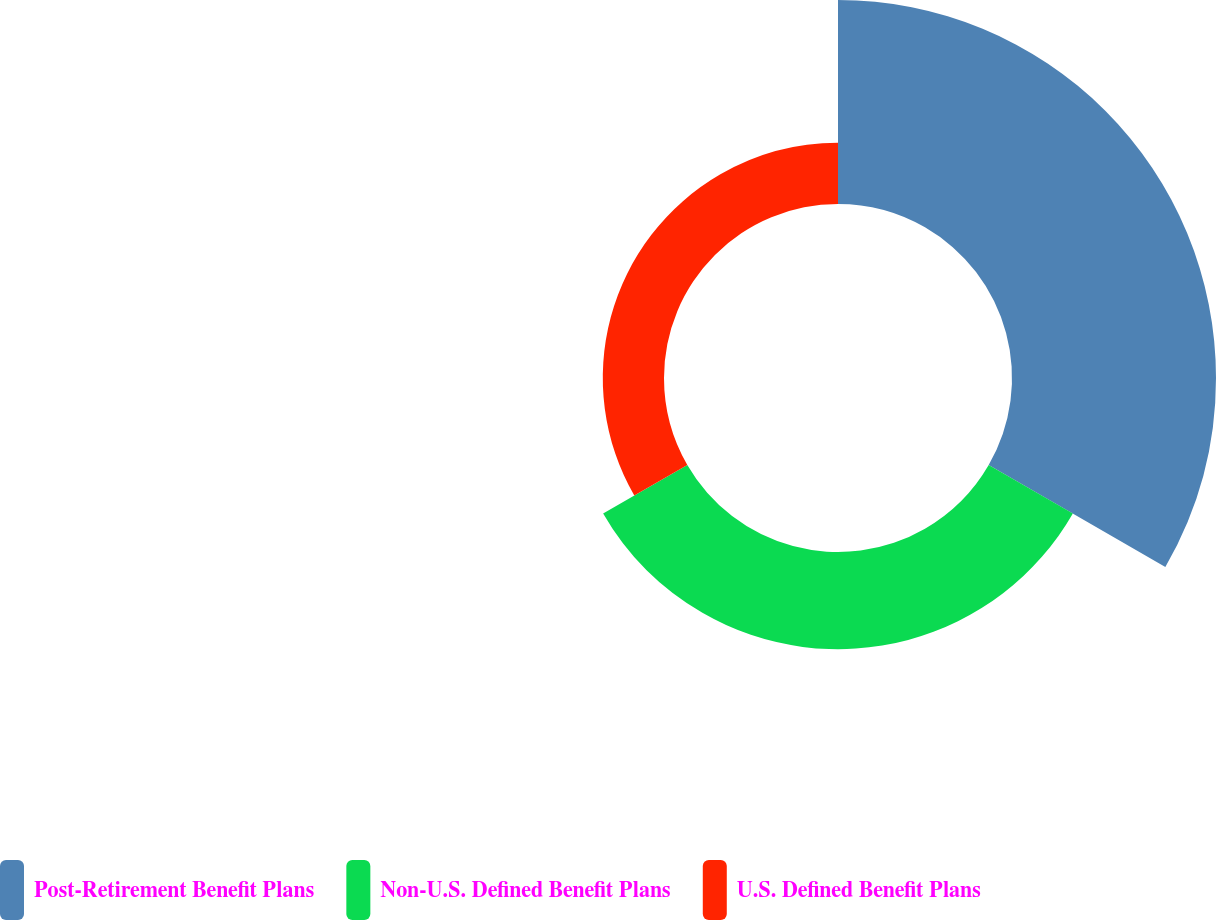<chart> <loc_0><loc_0><loc_500><loc_500><pie_chart><fcel>Post-Retirement Benefit Plans<fcel>Non-U.S. Defined Benefit Plans<fcel>U.S. Defined Benefit Plans<nl><fcel>56.29%<fcel>26.82%<fcel>16.89%<nl></chart> 